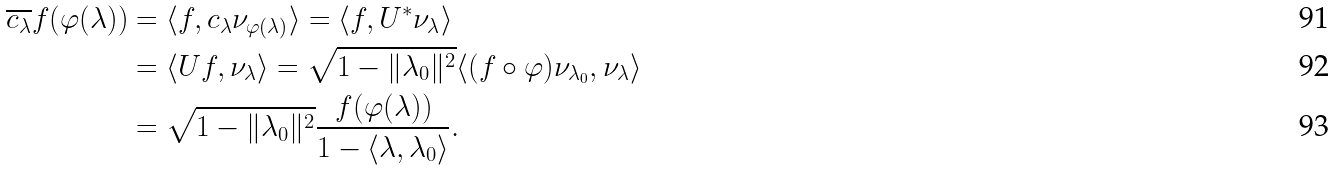Convert formula to latex. <formula><loc_0><loc_0><loc_500><loc_500>\overline { c _ { \lambda } } f ( \varphi ( \lambda ) ) & = \langle f , c _ { \lambda } \nu _ { \varphi ( \lambda ) } \rangle = \langle f , U ^ { * } \nu _ { \lambda } \rangle \\ & = \langle U f , \nu _ { \lambda } \rangle = \sqrt { 1 - \| \lambda _ { 0 } \| ^ { 2 } } \langle ( f \circ \varphi ) \nu _ { \lambda _ { 0 } } , \nu _ { \lambda } \rangle \\ & = \sqrt { 1 - \| \lambda _ { 0 } \| ^ { 2 } } \frac { f ( \varphi ( \lambda ) ) } { 1 - \langle \lambda , \lambda _ { 0 } \rangle } .</formula> 